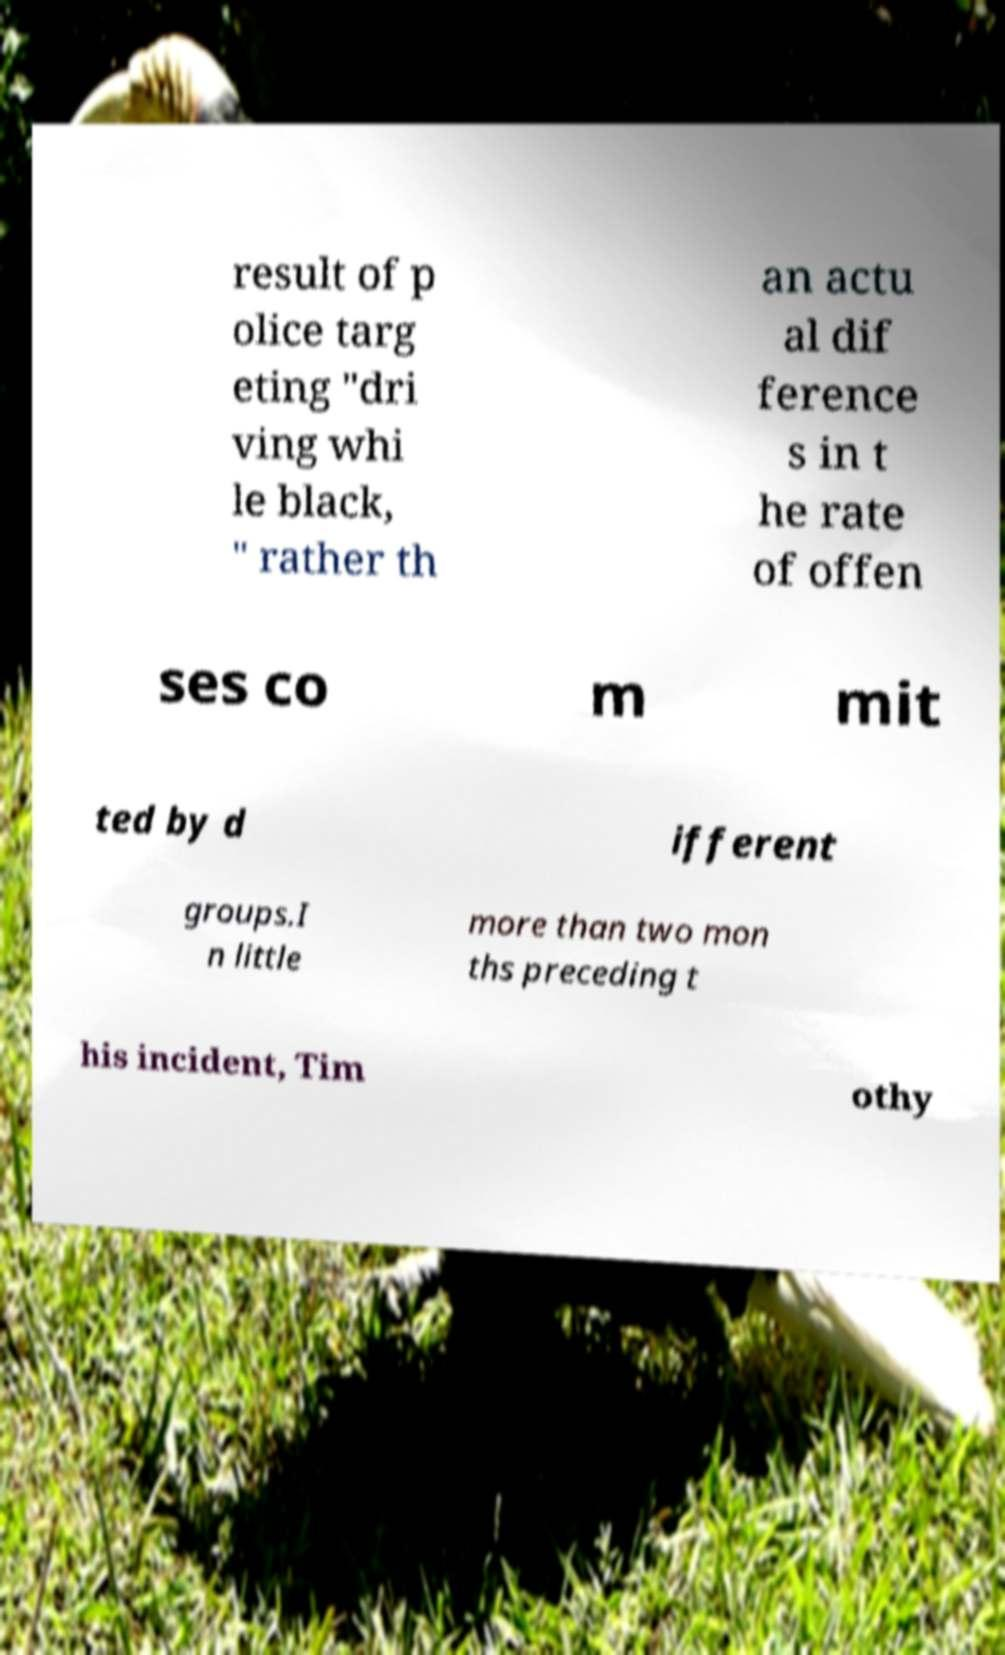Could you extract and type out the text from this image? result of p olice targ eting "dri ving whi le black, " rather th an actu al dif ference s in t he rate of offen ses co m mit ted by d ifferent groups.I n little more than two mon ths preceding t his incident, Tim othy 